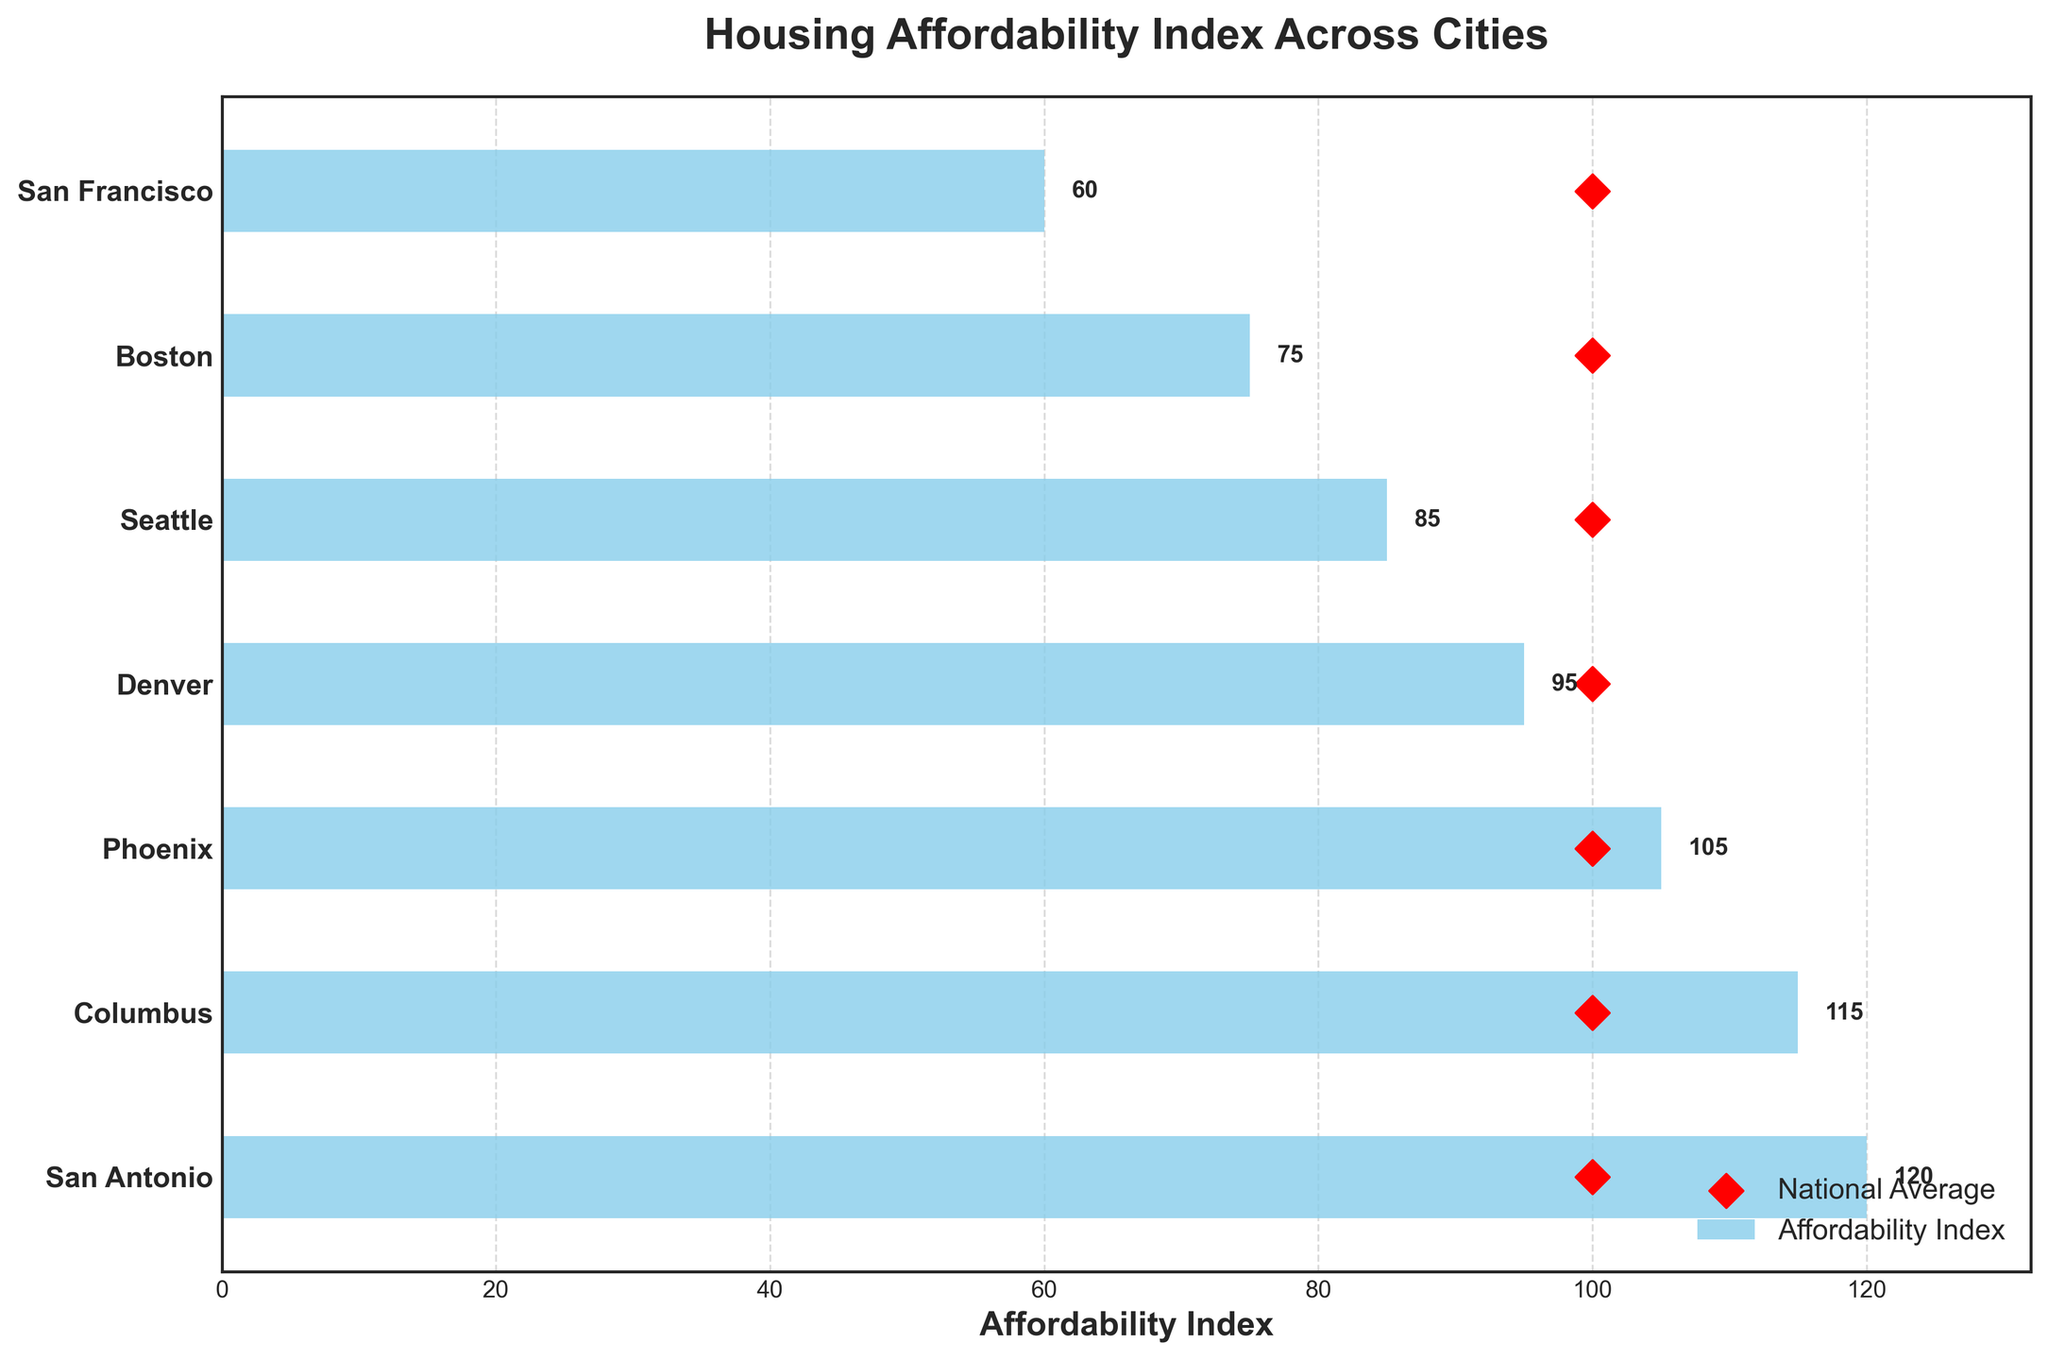What is the highest affordability index among the cities? The highest affordability index is denoted by the bar that extends the furthest to the right. San Antonio has the longest bar in the plot, indicating it has the highest index.
Answer: 120 Which city has the lowest affordability index? The shortest bar on the plot represents the lowest affordability index. San Francisco has the shortest bar.
Answer: 60 How does the national average affordability index compare across the cities? The national average is represented by a red diamond symbol. For each city, the red diamond is marked at the value of 100, which is the national average across all cities.
Answer: 100 Which cities have affordability indices above the national average? The cities where the bars extend past the red diamond symbol (which marks the national average) have affordability indices above the national average. This includes San Antonio, Columbus, and Phoenix.
Answer: San Antonio, Columbus, Phoenix How many cities have affordability indices below the national average? By counting the cities where the affordability index bar does not reach or go beyond the red diamond (national average), we find Denver, Seattle, Boston, and San Francisco. This makes a total of 4 cities.
Answer: 4 What is the difference in affordability index between the most and least affordable cities? The difference is calculated by subtracting the lowest affordability index (San Francisco, 60) from the highest affordability index (San Antonio, 120). The calculation is 120 - 60.
Answer: 60 Which cities have affordability indices between 90 and 110? The cities whose bars fall within the range of 90 to 110 on the x-axis are Denver and Phoenix.
Answer: Denver, Phoenix Rank the cities from most to least affordable based on the affordability index. Sorting the cities based on the height of their bars from longest to shortest results in the following order: San Antonio (120), Columbus (115), Phoenix (105), Denver (95), Seattle (85), Boston (75), San Francisco (60).
Answer: San Antonio, Columbus, Phoenix, Denver, Seattle, Boston, San Francisco What is the average affordability index for the cities listed? Sum the affordability indices and divide by the number of cities: (120 + 115 + 105 + 95 + 85 + 75 + 60) / 7 = 655 / 7. This calculation gives the average.
Answer: 93.57 